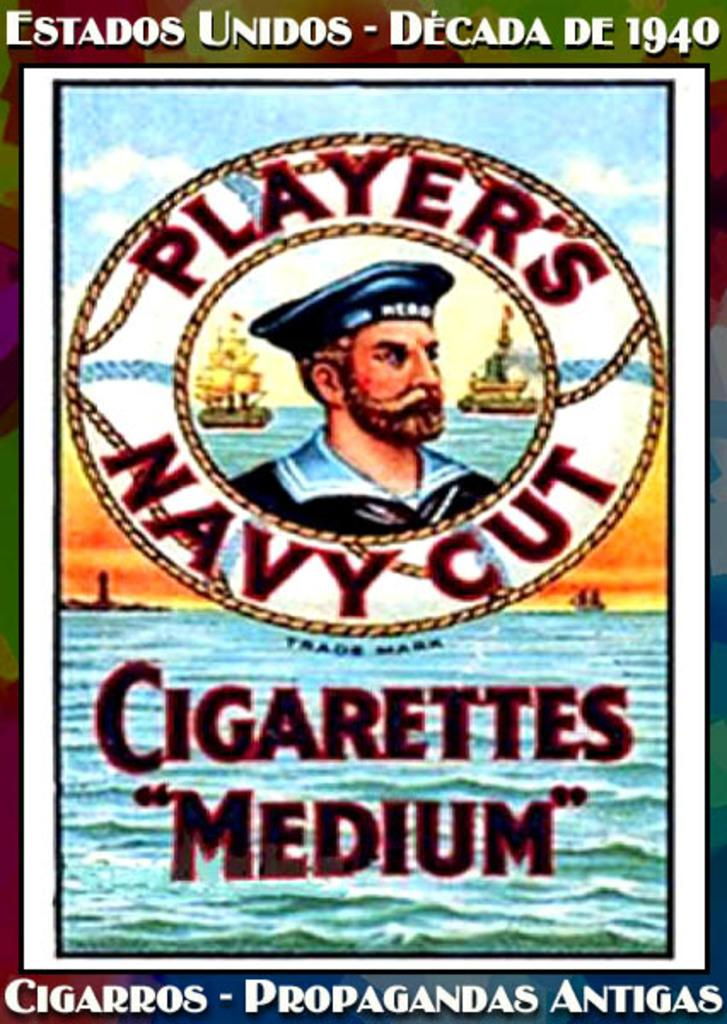<image>
Create a compact narrative representing the image presented. a poster that says 'player's navy cut' on it 